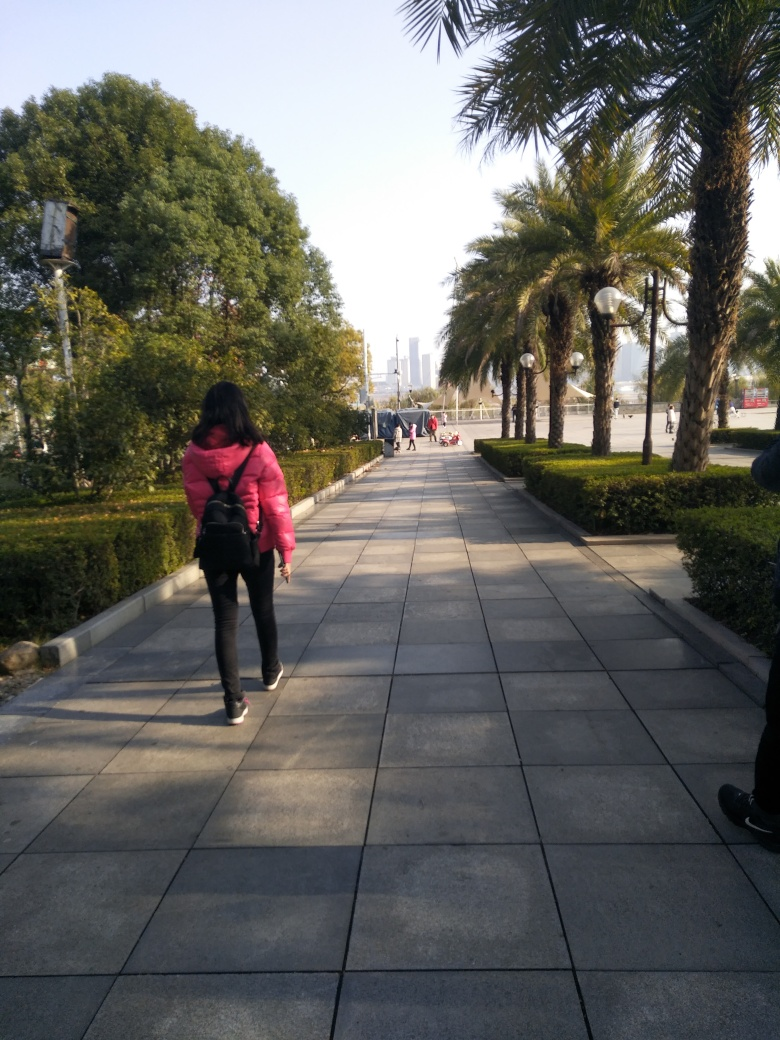What can be inferred about the location of this image? The image likely depicts a pathway in a public or recreational area, indicated by the presence of walking pedestrians, neatly arranged paving tiles, and well-maintained vegetation such as palm trees and shrubs. The presence of tall buildings in the background suggests the scene is near an urban environment, potentially on the outskirts of a city center or in a developed suburban area. 